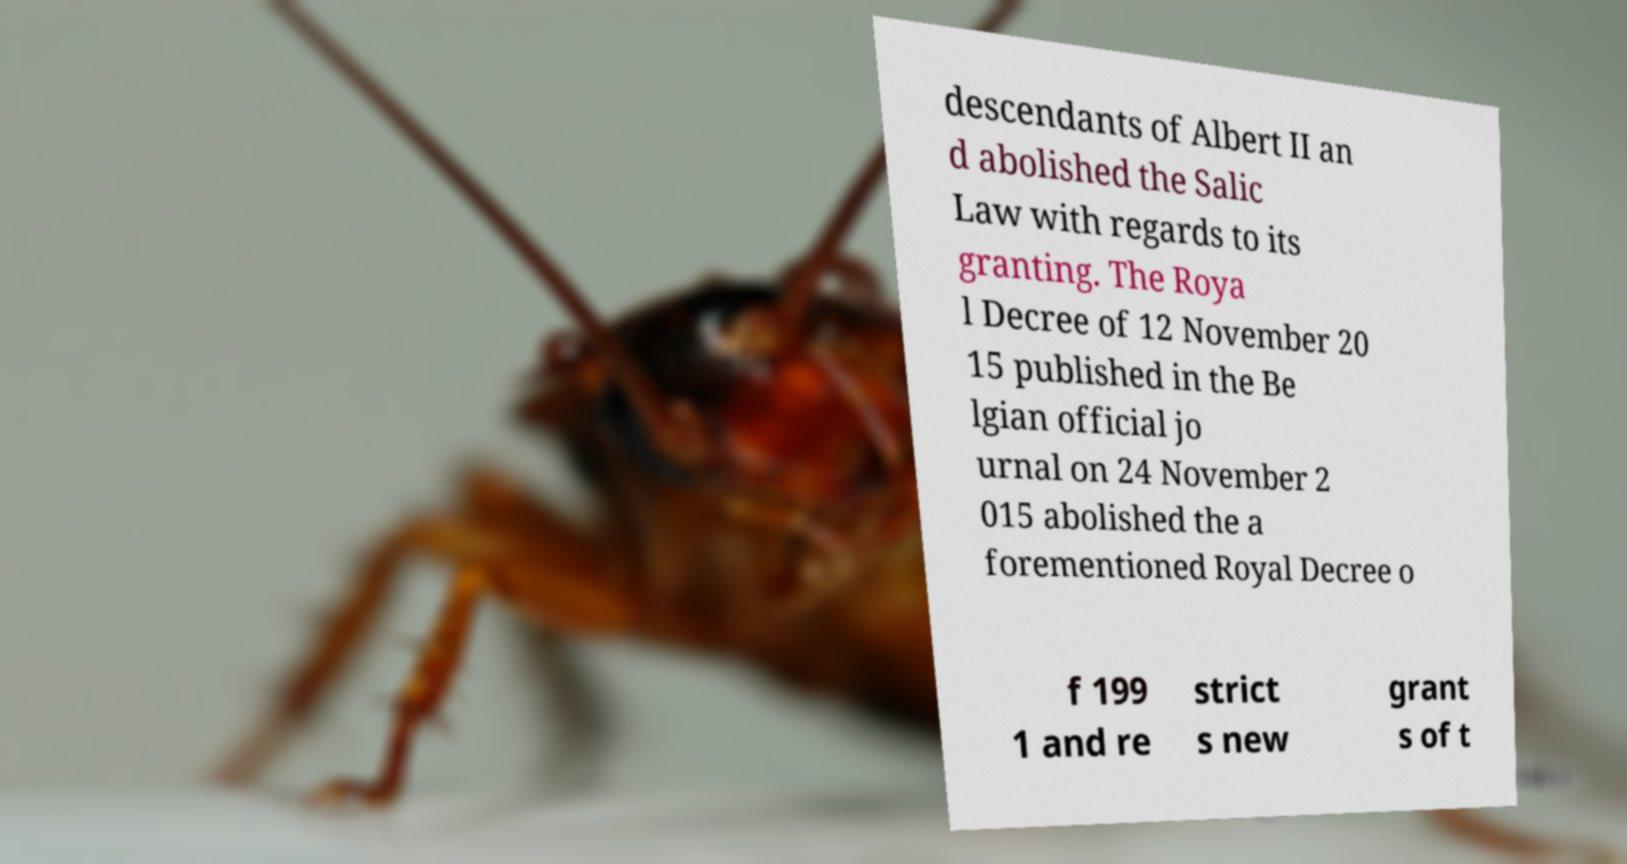Please identify and transcribe the text found in this image. descendants of Albert II an d abolished the Salic Law with regards to its granting. The Roya l Decree of 12 November 20 15 published in the Be lgian official jo urnal on 24 November 2 015 abolished the a forementioned Royal Decree o f 199 1 and re strict s new grant s of t 